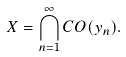<formula> <loc_0><loc_0><loc_500><loc_500>X = \bigcap _ { n = 1 } ^ { \infty } C O ( y _ { n } ) .</formula> 